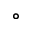Convert formula to latex. <formula><loc_0><loc_0><loc_500><loc_500>\circ</formula> 